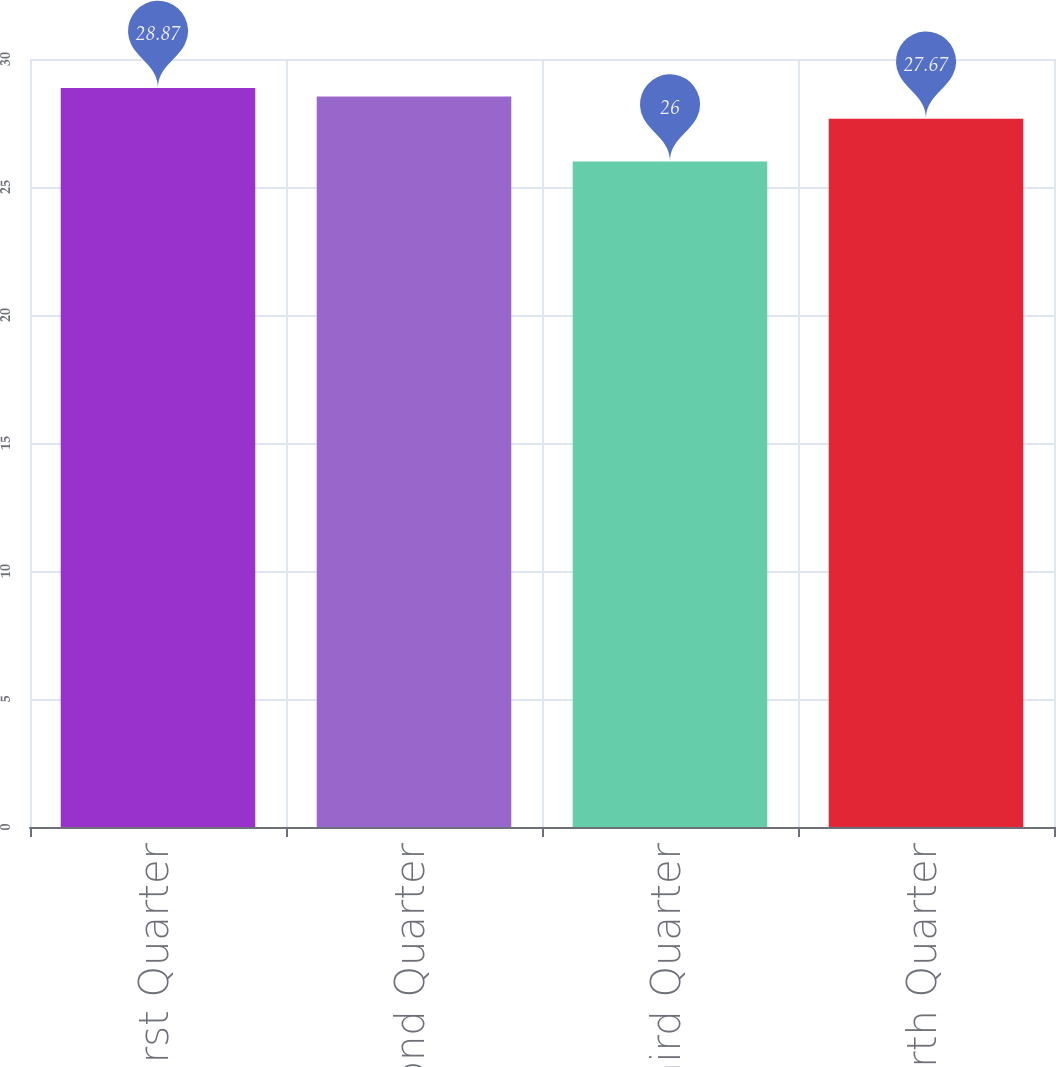Convert chart to OTSL. <chart><loc_0><loc_0><loc_500><loc_500><bar_chart><fcel>First Quarter<fcel>Second Quarter<fcel>Third Quarter<fcel>Fourth Quarter<nl><fcel>28.87<fcel>28.54<fcel>26<fcel>27.67<nl></chart> 